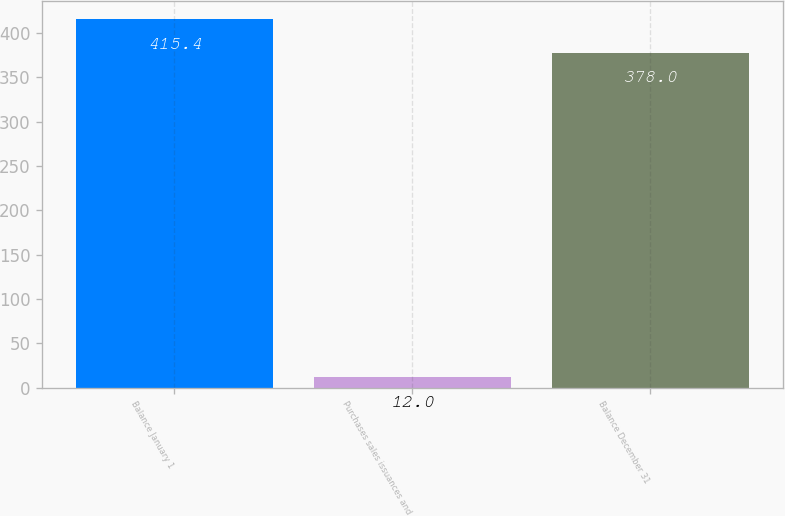Convert chart to OTSL. <chart><loc_0><loc_0><loc_500><loc_500><bar_chart><fcel>Balance January 1<fcel>Purchases sales issuances and<fcel>Balance December 31<nl><fcel>415.4<fcel>12<fcel>378<nl></chart> 